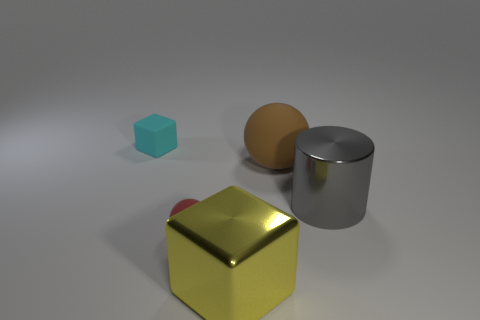Can you compare the relative sizes of the cyan cube and the golden cube? Certainly, the cyan cube is significantly smaller than the golden cube. The golden cube's edges are larger, indicating a greater overall volume, while the cyan cube has much shorter edges, making it look like a miniature in comparison. 